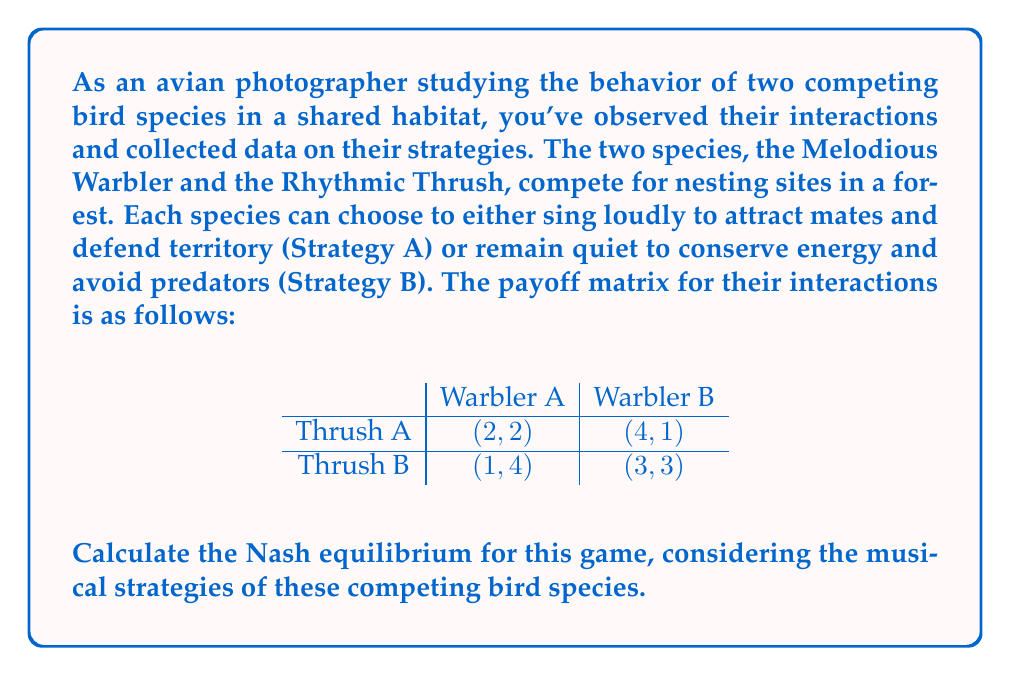Can you solve this math problem? To find the Nash equilibrium, we need to determine the best response for each player given the other player's strategy. Let's approach this step-by-step:

1. First, let's consider the Melodious Warbler's perspective:
   - If the Rhythmic Thrush chooses Strategy A (sing loudly):
     Warbler's payoff for A: 2
     Warbler's payoff for B: 1
     Best response: Strategy A
   - If the Rhythmic Thrush chooses Strategy B (remain quiet):
     Warbler's payoff for A: 4
     Warbler's payoff for B: 3
     Best response: Strategy A

2. Now, let's consider the Rhythmic Thrush's perspective:
   - If the Melodious Warbler chooses Strategy A (sing loudly):
     Thrush's payoff for A: 2
     Thrush's payoff for B: 1
     Best response: Strategy A
   - If the Melodious Warbler chooses Strategy B (remain quiet):
     Thrush's payoff for A: 4
     Thrush's payoff for B: 3
     Best response: Strategy A

3. We can see that regardless of what the other player does, both the Melodious Warbler and the Rhythmic Thrush always prefer Strategy A (sing loudly).

4. This means that the Nash equilibrium is (Thrush A, Warbler A), or in other words, both species will choose to sing loudly.

5. We can verify this by checking that neither player has an incentive to unilaterally deviate from this strategy:
   - If the Thrush switches to B while the Warbler stays at A, its payoff decreases from 2 to 1.
   - If the Warbler switches to B while the Thrush stays at A, its payoff decreases from 2 to 1.

Therefore, (Thrush A, Warbler A) is indeed a Nash equilibrium, and it's the only one in this game.
Answer: The Nash equilibrium for this game is (Thrush A, Warbler A), where both bird species choose Strategy A (sing loudly). The payoff for each species in this equilibrium is 2. 